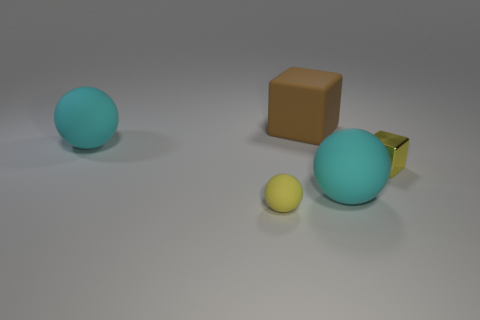There is a big rubber ball in front of the metal cube; does it have the same color as the small shiny cube in front of the brown object? no 